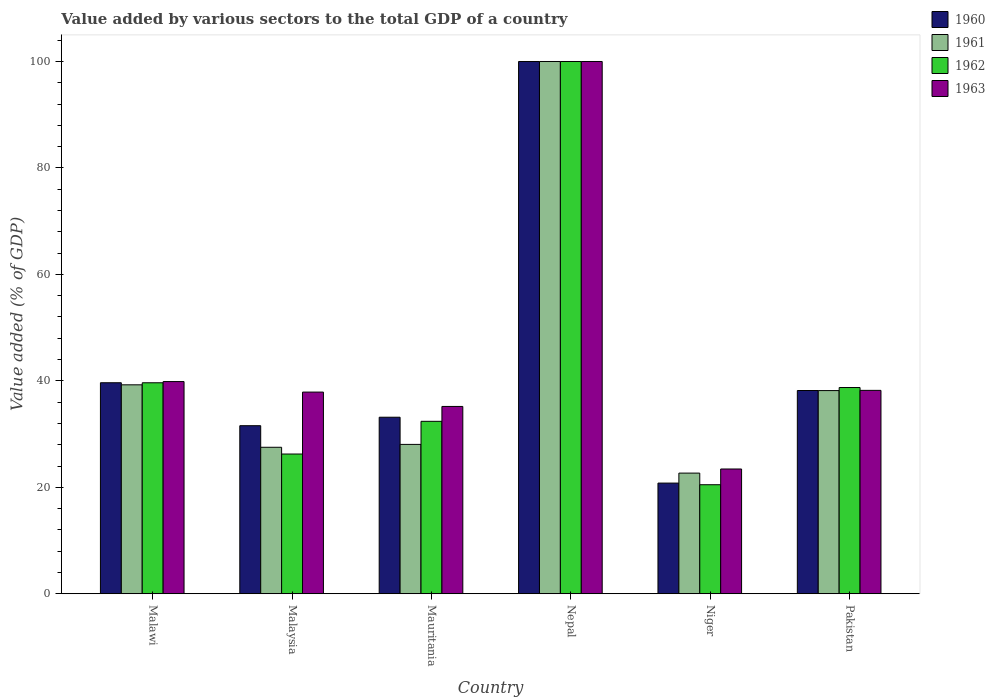How many groups of bars are there?
Keep it short and to the point. 6. How many bars are there on the 5th tick from the left?
Offer a terse response. 4. What is the label of the 2nd group of bars from the left?
Provide a short and direct response. Malaysia. What is the value added by various sectors to the total GDP in 1960 in Pakistan?
Provide a succinct answer. 38.18. Across all countries, what is the minimum value added by various sectors to the total GDP in 1962?
Your answer should be compact. 20.48. In which country was the value added by various sectors to the total GDP in 1962 maximum?
Offer a very short reply. Nepal. In which country was the value added by various sectors to the total GDP in 1963 minimum?
Give a very brief answer. Niger. What is the total value added by various sectors to the total GDP in 1963 in the graph?
Your response must be concise. 274.59. What is the difference between the value added by various sectors to the total GDP in 1961 in Malawi and that in Malaysia?
Provide a succinct answer. 11.73. What is the difference between the value added by various sectors to the total GDP in 1960 in Malaysia and the value added by various sectors to the total GDP in 1963 in Malawi?
Provide a succinct answer. -8.29. What is the average value added by various sectors to the total GDP in 1963 per country?
Make the answer very short. 45.76. What is the difference between the value added by various sectors to the total GDP of/in 1963 and value added by various sectors to the total GDP of/in 1961 in Malawi?
Offer a very short reply. 0.61. What is the ratio of the value added by various sectors to the total GDP in 1960 in Mauritania to that in Niger?
Offer a terse response. 1.6. Is the difference between the value added by various sectors to the total GDP in 1963 in Nepal and Pakistan greater than the difference between the value added by various sectors to the total GDP in 1961 in Nepal and Pakistan?
Your answer should be very brief. No. What is the difference between the highest and the second highest value added by various sectors to the total GDP in 1963?
Offer a very short reply. 61.79. What is the difference between the highest and the lowest value added by various sectors to the total GDP in 1963?
Your answer should be very brief. 76.56. Is the sum of the value added by various sectors to the total GDP in 1963 in Nepal and Pakistan greater than the maximum value added by various sectors to the total GDP in 1960 across all countries?
Offer a very short reply. Yes. What does the 4th bar from the left in Pakistan represents?
Provide a short and direct response. 1963. What does the 4th bar from the right in Niger represents?
Keep it short and to the point. 1960. How many bars are there?
Give a very brief answer. 24. Are all the bars in the graph horizontal?
Keep it short and to the point. No. Are the values on the major ticks of Y-axis written in scientific E-notation?
Provide a succinct answer. No. Does the graph contain grids?
Offer a terse response. No. How many legend labels are there?
Your answer should be very brief. 4. What is the title of the graph?
Provide a short and direct response. Value added by various sectors to the total GDP of a country. What is the label or title of the X-axis?
Provide a short and direct response. Country. What is the label or title of the Y-axis?
Make the answer very short. Value added (% of GDP). What is the Value added (% of GDP) of 1960 in Malawi?
Keep it short and to the point. 39.64. What is the Value added (% of GDP) in 1961 in Malawi?
Provide a succinct answer. 39.25. What is the Value added (% of GDP) of 1962 in Malawi?
Ensure brevity in your answer.  39.64. What is the Value added (% of GDP) in 1963 in Malawi?
Your response must be concise. 39.86. What is the Value added (% of GDP) of 1960 in Malaysia?
Offer a very short reply. 31.57. What is the Value added (% of GDP) in 1961 in Malaysia?
Offer a terse response. 27.52. What is the Value added (% of GDP) in 1962 in Malaysia?
Your answer should be very brief. 26.25. What is the Value added (% of GDP) in 1963 in Malaysia?
Offer a very short reply. 37.89. What is the Value added (% of GDP) in 1960 in Mauritania?
Offer a very short reply. 33.17. What is the Value added (% of GDP) of 1961 in Mauritania?
Offer a terse response. 28.06. What is the Value added (% of GDP) in 1962 in Mauritania?
Your response must be concise. 32.4. What is the Value added (% of GDP) of 1963 in Mauritania?
Your response must be concise. 35.19. What is the Value added (% of GDP) of 1960 in Niger?
Your response must be concise. 20.79. What is the Value added (% of GDP) of 1961 in Niger?
Offer a terse response. 22.67. What is the Value added (% of GDP) of 1962 in Niger?
Your answer should be very brief. 20.48. What is the Value added (% of GDP) of 1963 in Niger?
Provide a succinct answer. 23.44. What is the Value added (% of GDP) in 1960 in Pakistan?
Your answer should be compact. 38.18. What is the Value added (% of GDP) in 1961 in Pakistan?
Your answer should be very brief. 38.17. What is the Value added (% of GDP) of 1962 in Pakistan?
Your answer should be compact. 38.74. What is the Value added (% of GDP) in 1963 in Pakistan?
Offer a very short reply. 38.21. Across all countries, what is the maximum Value added (% of GDP) in 1963?
Make the answer very short. 100. Across all countries, what is the minimum Value added (% of GDP) of 1960?
Offer a terse response. 20.79. Across all countries, what is the minimum Value added (% of GDP) in 1961?
Your response must be concise. 22.67. Across all countries, what is the minimum Value added (% of GDP) in 1962?
Keep it short and to the point. 20.48. Across all countries, what is the minimum Value added (% of GDP) of 1963?
Offer a terse response. 23.44. What is the total Value added (% of GDP) of 1960 in the graph?
Your answer should be compact. 263.36. What is the total Value added (% of GDP) in 1961 in the graph?
Your answer should be very brief. 255.67. What is the total Value added (% of GDP) of 1962 in the graph?
Offer a very short reply. 257.51. What is the total Value added (% of GDP) of 1963 in the graph?
Provide a succinct answer. 274.59. What is the difference between the Value added (% of GDP) in 1960 in Malawi and that in Malaysia?
Your answer should be compact. 8.07. What is the difference between the Value added (% of GDP) of 1961 in Malawi and that in Malaysia?
Provide a succinct answer. 11.73. What is the difference between the Value added (% of GDP) of 1962 in Malawi and that in Malaysia?
Offer a very short reply. 13.39. What is the difference between the Value added (% of GDP) in 1963 in Malawi and that in Malaysia?
Your answer should be compact. 1.98. What is the difference between the Value added (% of GDP) of 1960 in Malawi and that in Mauritania?
Make the answer very short. 6.48. What is the difference between the Value added (% of GDP) of 1961 in Malawi and that in Mauritania?
Make the answer very short. 11.2. What is the difference between the Value added (% of GDP) in 1962 in Malawi and that in Mauritania?
Offer a very short reply. 7.24. What is the difference between the Value added (% of GDP) in 1963 in Malawi and that in Mauritania?
Keep it short and to the point. 4.67. What is the difference between the Value added (% of GDP) of 1960 in Malawi and that in Nepal?
Your answer should be very brief. -60.36. What is the difference between the Value added (% of GDP) in 1961 in Malawi and that in Nepal?
Your answer should be very brief. -60.75. What is the difference between the Value added (% of GDP) in 1962 in Malawi and that in Nepal?
Offer a very short reply. -60.36. What is the difference between the Value added (% of GDP) in 1963 in Malawi and that in Nepal?
Give a very brief answer. -60.14. What is the difference between the Value added (% of GDP) of 1960 in Malawi and that in Niger?
Give a very brief answer. 18.85. What is the difference between the Value added (% of GDP) of 1961 in Malawi and that in Niger?
Ensure brevity in your answer.  16.59. What is the difference between the Value added (% of GDP) of 1962 in Malawi and that in Niger?
Make the answer very short. 19.15. What is the difference between the Value added (% of GDP) of 1963 in Malawi and that in Niger?
Your response must be concise. 16.42. What is the difference between the Value added (% of GDP) in 1960 in Malawi and that in Pakistan?
Your answer should be compact. 1.46. What is the difference between the Value added (% of GDP) in 1961 in Malawi and that in Pakistan?
Offer a terse response. 1.08. What is the difference between the Value added (% of GDP) in 1962 in Malawi and that in Pakistan?
Provide a succinct answer. 0.89. What is the difference between the Value added (% of GDP) of 1963 in Malawi and that in Pakistan?
Give a very brief answer. 1.65. What is the difference between the Value added (% of GDP) in 1960 in Malaysia and that in Mauritania?
Offer a terse response. -1.59. What is the difference between the Value added (% of GDP) of 1961 in Malaysia and that in Mauritania?
Your response must be concise. -0.54. What is the difference between the Value added (% of GDP) of 1962 in Malaysia and that in Mauritania?
Provide a short and direct response. -6.15. What is the difference between the Value added (% of GDP) in 1963 in Malaysia and that in Mauritania?
Offer a terse response. 2.7. What is the difference between the Value added (% of GDP) of 1960 in Malaysia and that in Nepal?
Your answer should be compact. -68.43. What is the difference between the Value added (% of GDP) of 1961 in Malaysia and that in Nepal?
Your response must be concise. -72.48. What is the difference between the Value added (% of GDP) of 1962 in Malaysia and that in Nepal?
Provide a succinct answer. -73.75. What is the difference between the Value added (% of GDP) in 1963 in Malaysia and that in Nepal?
Your response must be concise. -62.11. What is the difference between the Value added (% of GDP) of 1960 in Malaysia and that in Niger?
Offer a very short reply. 10.78. What is the difference between the Value added (% of GDP) of 1961 in Malaysia and that in Niger?
Give a very brief answer. 4.85. What is the difference between the Value added (% of GDP) of 1962 in Malaysia and that in Niger?
Give a very brief answer. 5.77. What is the difference between the Value added (% of GDP) in 1963 in Malaysia and that in Niger?
Offer a terse response. 14.45. What is the difference between the Value added (% of GDP) in 1960 in Malaysia and that in Pakistan?
Your response must be concise. -6.61. What is the difference between the Value added (% of GDP) in 1961 in Malaysia and that in Pakistan?
Provide a short and direct response. -10.65. What is the difference between the Value added (% of GDP) of 1962 in Malaysia and that in Pakistan?
Give a very brief answer. -12.5. What is the difference between the Value added (% of GDP) in 1963 in Malaysia and that in Pakistan?
Your answer should be very brief. -0.32. What is the difference between the Value added (% of GDP) of 1960 in Mauritania and that in Nepal?
Make the answer very short. -66.83. What is the difference between the Value added (% of GDP) of 1961 in Mauritania and that in Nepal?
Keep it short and to the point. -71.94. What is the difference between the Value added (% of GDP) in 1962 in Mauritania and that in Nepal?
Make the answer very short. -67.6. What is the difference between the Value added (% of GDP) of 1963 in Mauritania and that in Nepal?
Keep it short and to the point. -64.81. What is the difference between the Value added (% of GDP) of 1960 in Mauritania and that in Niger?
Offer a very short reply. 12.38. What is the difference between the Value added (% of GDP) in 1961 in Mauritania and that in Niger?
Keep it short and to the point. 5.39. What is the difference between the Value added (% of GDP) of 1962 in Mauritania and that in Niger?
Provide a short and direct response. 11.91. What is the difference between the Value added (% of GDP) of 1963 in Mauritania and that in Niger?
Keep it short and to the point. 11.75. What is the difference between the Value added (% of GDP) of 1960 in Mauritania and that in Pakistan?
Give a very brief answer. -5.02. What is the difference between the Value added (% of GDP) in 1961 in Mauritania and that in Pakistan?
Your answer should be very brief. -10.11. What is the difference between the Value added (% of GDP) of 1962 in Mauritania and that in Pakistan?
Give a very brief answer. -6.35. What is the difference between the Value added (% of GDP) in 1963 in Mauritania and that in Pakistan?
Ensure brevity in your answer.  -3.02. What is the difference between the Value added (% of GDP) of 1960 in Nepal and that in Niger?
Ensure brevity in your answer.  79.21. What is the difference between the Value added (% of GDP) of 1961 in Nepal and that in Niger?
Provide a short and direct response. 77.33. What is the difference between the Value added (% of GDP) of 1962 in Nepal and that in Niger?
Your answer should be very brief. 79.52. What is the difference between the Value added (% of GDP) in 1963 in Nepal and that in Niger?
Offer a very short reply. 76.56. What is the difference between the Value added (% of GDP) of 1960 in Nepal and that in Pakistan?
Offer a very short reply. 61.82. What is the difference between the Value added (% of GDP) in 1961 in Nepal and that in Pakistan?
Your answer should be compact. 61.83. What is the difference between the Value added (% of GDP) in 1962 in Nepal and that in Pakistan?
Your answer should be compact. 61.26. What is the difference between the Value added (% of GDP) in 1963 in Nepal and that in Pakistan?
Provide a succinct answer. 61.79. What is the difference between the Value added (% of GDP) of 1960 in Niger and that in Pakistan?
Make the answer very short. -17.39. What is the difference between the Value added (% of GDP) in 1961 in Niger and that in Pakistan?
Your answer should be compact. -15.5. What is the difference between the Value added (% of GDP) of 1962 in Niger and that in Pakistan?
Provide a short and direct response. -18.26. What is the difference between the Value added (% of GDP) of 1963 in Niger and that in Pakistan?
Keep it short and to the point. -14.77. What is the difference between the Value added (% of GDP) of 1960 in Malawi and the Value added (% of GDP) of 1961 in Malaysia?
Ensure brevity in your answer.  12.13. What is the difference between the Value added (% of GDP) of 1960 in Malawi and the Value added (% of GDP) of 1962 in Malaysia?
Offer a terse response. 13.39. What is the difference between the Value added (% of GDP) of 1960 in Malawi and the Value added (% of GDP) of 1963 in Malaysia?
Your answer should be compact. 1.76. What is the difference between the Value added (% of GDP) of 1961 in Malawi and the Value added (% of GDP) of 1962 in Malaysia?
Your response must be concise. 13. What is the difference between the Value added (% of GDP) of 1961 in Malawi and the Value added (% of GDP) of 1963 in Malaysia?
Ensure brevity in your answer.  1.37. What is the difference between the Value added (% of GDP) of 1962 in Malawi and the Value added (% of GDP) of 1963 in Malaysia?
Offer a terse response. 1.75. What is the difference between the Value added (% of GDP) in 1960 in Malawi and the Value added (% of GDP) in 1961 in Mauritania?
Make the answer very short. 11.59. What is the difference between the Value added (% of GDP) of 1960 in Malawi and the Value added (% of GDP) of 1962 in Mauritania?
Give a very brief answer. 7.25. What is the difference between the Value added (% of GDP) of 1960 in Malawi and the Value added (% of GDP) of 1963 in Mauritania?
Your answer should be very brief. 4.45. What is the difference between the Value added (% of GDP) of 1961 in Malawi and the Value added (% of GDP) of 1962 in Mauritania?
Offer a very short reply. 6.86. What is the difference between the Value added (% of GDP) of 1961 in Malawi and the Value added (% of GDP) of 1963 in Mauritania?
Give a very brief answer. 4.06. What is the difference between the Value added (% of GDP) of 1962 in Malawi and the Value added (% of GDP) of 1963 in Mauritania?
Make the answer very short. 4.45. What is the difference between the Value added (% of GDP) of 1960 in Malawi and the Value added (% of GDP) of 1961 in Nepal?
Give a very brief answer. -60.36. What is the difference between the Value added (% of GDP) of 1960 in Malawi and the Value added (% of GDP) of 1962 in Nepal?
Your answer should be compact. -60.36. What is the difference between the Value added (% of GDP) of 1960 in Malawi and the Value added (% of GDP) of 1963 in Nepal?
Offer a terse response. -60.36. What is the difference between the Value added (% of GDP) in 1961 in Malawi and the Value added (% of GDP) in 1962 in Nepal?
Ensure brevity in your answer.  -60.75. What is the difference between the Value added (% of GDP) in 1961 in Malawi and the Value added (% of GDP) in 1963 in Nepal?
Make the answer very short. -60.75. What is the difference between the Value added (% of GDP) of 1962 in Malawi and the Value added (% of GDP) of 1963 in Nepal?
Provide a short and direct response. -60.36. What is the difference between the Value added (% of GDP) of 1960 in Malawi and the Value added (% of GDP) of 1961 in Niger?
Provide a short and direct response. 16.98. What is the difference between the Value added (% of GDP) in 1960 in Malawi and the Value added (% of GDP) in 1962 in Niger?
Give a very brief answer. 19.16. What is the difference between the Value added (% of GDP) of 1960 in Malawi and the Value added (% of GDP) of 1963 in Niger?
Ensure brevity in your answer.  16.21. What is the difference between the Value added (% of GDP) of 1961 in Malawi and the Value added (% of GDP) of 1962 in Niger?
Offer a very short reply. 18.77. What is the difference between the Value added (% of GDP) in 1961 in Malawi and the Value added (% of GDP) in 1963 in Niger?
Give a very brief answer. 15.81. What is the difference between the Value added (% of GDP) in 1962 in Malawi and the Value added (% of GDP) in 1963 in Niger?
Give a very brief answer. 16.2. What is the difference between the Value added (% of GDP) of 1960 in Malawi and the Value added (% of GDP) of 1961 in Pakistan?
Offer a very short reply. 1.48. What is the difference between the Value added (% of GDP) of 1960 in Malawi and the Value added (% of GDP) of 1962 in Pakistan?
Offer a very short reply. 0.9. What is the difference between the Value added (% of GDP) of 1960 in Malawi and the Value added (% of GDP) of 1963 in Pakistan?
Your answer should be very brief. 1.43. What is the difference between the Value added (% of GDP) in 1961 in Malawi and the Value added (% of GDP) in 1962 in Pakistan?
Keep it short and to the point. 0.51. What is the difference between the Value added (% of GDP) in 1961 in Malawi and the Value added (% of GDP) in 1963 in Pakistan?
Offer a terse response. 1.04. What is the difference between the Value added (% of GDP) in 1962 in Malawi and the Value added (% of GDP) in 1963 in Pakistan?
Give a very brief answer. 1.43. What is the difference between the Value added (% of GDP) of 1960 in Malaysia and the Value added (% of GDP) of 1961 in Mauritania?
Give a very brief answer. 3.51. What is the difference between the Value added (% of GDP) of 1960 in Malaysia and the Value added (% of GDP) of 1962 in Mauritania?
Make the answer very short. -0.82. What is the difference between the Value added (% of GDP) in 1960 in Malaysia and the Value added (% of GDP) in 1963 in Mauritania?
Keep it short and to the point. -3.62. What is the difference between the Value added (% of GDP) in 1961 in Malaysia and the Value added (% of GDP) in 1962 in Mauritania?
Make the answer very short. -4.88. What is the difference between the Value added (% of GDP) of 1961 in Malaysia and the Value added (% of GDP) of 1963 in Mauritania?
Offer a terse response. -7.67. What is the difference between the Value added (% of GDP) of 1962 in Malaysia and the Value added (% of GDP) of 1963 in Mauritania?
Make the answer very short. -8.94. What is the difference between the Value added (% of GDP) of 1960 in Malaysia and the Value added (% of GDP) of 1961 in Nepal?
Give a very brief answer. -68.43. What is the difference between the Value added (% of GDP) in 1960 in Malaysia and the Value added (% of GDP) in 1962 in Nepal?
Your response must be concise. -68.43. What is the difference between the Value added (% of GDP) of 1960 in Malaysia and the Value added (% of GDP) of 1963 in Nepal?
Keep it short and to the point. -68.43. What is the difference between the Value added (% of GDP) of 1961 in Malaysia and the Value added (% of GDP) of 1962 in Nepal?
Your answer should be compact. -72.48. What is the difference between the Value added (% of GDP) of 1961 in Malaysia and the Value added (% of GDP) of 1963 in Nepal?
Your response must be concise. -72.48. What is the difference between the Value added (% of GDP) of 1962 in Malaysia and the Value added (% of GDP) of 1963 in Nepal?
Your answer should be very brief. -73.75. What is the difference between the Value added (% of GDP) of 1960 in Malaysia and the Value added (% of GDP) of 1961 in Niger?
Your response must be concise. 8.91. What is the difference between the Value added (% of GDP) of 1960 in Malaysia and the Value added (% of GDP) of 1962 in Niger?
Your answer should be compact. 11.09. What is the difference between the Value added (% of GDP) in 1960 in Malaysia and the Value added (% of GDP) in 1963 in Niger?
Provide a succinct answer. 8.13. What is the difference between the Value added (% of GDP) of 1961 in Malaysia and the Value added (% of GDP) of 1962 in Niger?
Provide a short and direct response. 7.04. What is the difference between the Value added (% of GDP) in 1961 in Malaysia and the Value added (% of GDP) in 1963 in Niger?
Provide a succinct answer. 4.08. What is the difference between the Value added (% of GDP) in 1962 in Malaysia and the Value added (% of GDP) in 1963 in Niger?
Make the answer very short. 2.81. What is the difference between the Value added (% of GDP) in 1960 in Malaysia and the Value added (% of GDP) in 1961 in Pakistan?
Keep it short and to the point. -6.6. What is the difference between the Value added (% of GDP) in 1960 in Malaysia and the Value added (% of GDP) in 1962 in Pakistan?
Your response must be concise. -7.17. What is the difference between the Value added (% of GDP) of 1960 in Malaysia and the Value added (% of GDP) of 1963 in Pakistan?
Provide a short and direct response. -6.64. What is the difference between the Value added (% of GDP) of 1961 in Malaysia and the Value added (% of GDP) of 1962 in Pakistan?
Your answer should be very brief. -11.23. What is the difference between the Value added (% of GDP) of 1961 in Malaysia and the Value added (% of GDP) of 1963 in Pakistan?
Your response must be concise. -10.69. What is the difference between the Value added (% of GDP) in 1962 in Malaysia and the Value added (% of GDP) in 1963 in Pakistan?
Give a very brief answer. -11.96. What is the difference between the Value added (% of GDP) in 1960 in Mauritania and the Value added (% of GDP) in 1961 in Nepal?
Your answer should be very brief. -66.83. What is the difference between the Value added (% of GDP) of 1960 in Mauritania and the Value added (% of GDP) of 1962 in Nepal?
Ensure brevity in your answer.  -66.83. What is the difference between the Value added (% of GDP) in 1960 in Mauritania and the Value added (% of GDP) in 1963 in Nepal?
Offer a very short reply. -66.83. What is the difference between the Value added (% of GDP) in 1961 in Mauritania and the Value added (% of GDP) in 1962 in Nepal?
Your answer should be compact. -71.94. What is the difference between the Value added (% of GDP) of 1961 in Mauritania and the Value added (% of GDP) of 1963 in Nepal?
Offer a terse response. -71.94. What is the difference between the Value added (% of GDP) in 1962 in Mauritania and the Value added (% of GDP) in 1963 in Nepal?
Ensure brevity in your answer.  -67.6. What is the difference between the Value added (% of GDP) of 1960 in Mauritania and the Value added (% of GDP) of 1961 in Niger?
Offer a very short reply. 10.5. What is the difference between the Value added (% of GDP) in 1960 in Mauritania and the Value added (% of GDP) in 1962 in Niger?
Your answer should be very brief. 12.68. What is the difference between the Value added (% of GDP) in 1960 in Mauritania and the Value added (% of GDP) in 1963 in Niger?
Give a very brief answer. 9.73. What is the difference between the Value added (% of GDP) of 1961 in Mauritania and the Value added (% of GDP) of 1962 in Niger?
Keep it short and to the point. 7.58. What is the difference between the Value added (% of GDP) in 1961 in Mauritania and the Value added (% of GDP) in 1963 in Niger?
Your answer should be very brief. 4.62. What is the difference between the Value added (% of GDP) in 1962 in Mauritania and the Value added (% of GDP) in 1963 in Niger?
Provide a succinct answer. 8.96. What is the difference between the Value added (% of GDP) in 1960 in Mauritania and the Value added (% of GDP) in 1961 in Pakistan?
Offer a terse response. -5. What is the difference between the Value added (% of GDP) in 1960 in Mauritania and the Value added (% of GDP) in 1962 in Pakistan?
Provide a short and direct response. -5.58. What is the difference between the Value added (% of GDP) in 1960 in Mauritania and the Value added (% of GDP) in 1963 in Pakistan?
Make the answer very short. -5.04. What is the difference between the Value added (% of GDP) in 1961 in Mauritania and the Value added (% of GDP) in 1962 in Pakistan?
Provide a succinct answer. -10.69. What is the difference between the Value added (% of GDP) of 1961 in Mauritania and the Value added (% of GDP) of 1963 in Pakistan?
Provide a short and direct response. -10.15. What is the difference between the Value added (% of GDP) of 1962 in Mauritania and the Value added (% of GDP) of 1963 in Pakistan?
Your answer should be very brief. -5.81. What is the difference between the Value added (% of GDP) in 1960 in Nepal and the Value added (% of GDP) in 1961 in Niger?
Make the answer very short. 77.33. What is the difference between the Value added (% of GDP) in 1960 in Nepal and the Value added (% of GDP) in 1962 in Niger?
Your answer should be very brief. 79.52. What is the difference between the Value added (% of GDP) of 1960 in Nepal and the Value added (% of GDP) of 1963 in Niger?
Offer a terse response. 76.56. What is the difference between the Value added (% of GDP) in 1961 in Nepal and the Value added (% of GDP) in 1962 in Niger?
Ensure brevity in your answer.  79.52. What is the difference between the Value added (% of GDP) of 1961 in Nepal and the Value added (% of GDP) of 1963 in Niger?
Your response must be concise. 76.56. What is the difference between the Value added (% of GDP) in 1962 in Nepal and the Value added (% of GDP) in 1963 in Niger?
Provide a short and direct response. 76.56. What is the difference between the Value added (% of GDP) of 1960 in Nepal and the Value added (% of GDP) of 1961 in Pakistan?
Offer a terse response. 61.83. What is the difference between the Value added (% of GDP) in 1960 in Nepal and the Value added (% of GDP) in 1962 in Pakistan?
Your response must be concise. 61.26. What is the difference between the Value added (% of GDP) in 1960 in Nepal and the Value added (% of GDP) in 1963 in Pakistan?
Offer a terse response. 61.79. What is the difference between the Value added (% of GDP) in 1961 in Nepal and the Value added (% of GDP) in 1962 in Pakistan?
Offer a terse response. 61.26. What is the difference between the Value added (% of GDP) in 1961 in Nepal and the Value added (% of GDP) in 1963 in Pakistan?
Provide a short and direct response. 61.79. What is the difference between the Value added (% of GDP) of 1962 in Nepal and the Value added (% of GDP) of 1963 in Pakistan?
Your answer should be very brief. 61.79. What is the difference between the Value added (% of GDP) of 1960 in Niger and the Value added (% of GDP) of 1961 in Pakistan?
Offer a very short reply. -17.38. What is the difference between the Value added (% of GDP) in 1960 in Niger and the Value added (% of GDP) in 1962 in Pakistan?
Provide a succinct answer. -17.95. What is the difference between the Value added (% of GDP) in 1960 in Niger and the Value added (% of GDP) in 1963 in Pakistan?
Provide a succinct answer. -17.42. What is the difference between the Value added (% of GDP) in 1961 in Niger and the Value added (% of GDP) in 1962 in Pakistan?
Make the answer very short. -16.08. What is the difference between the Value added (% of GDP) of 1961 in Niger and the Value added (% of GDP) of 1963 in Pakistan?
Ensure brevity in your answer.  -15.54. What is the difference between the Value added (% of GDP) in 1962 in Niger and the Value added (% of GDP) in 1963 in Pakistan?
Provide a short and direct response. -17.73. What is the average Value added (% of GDP) of 1960 per country?
Offer a very short reply. 43.89. What is the average Value added (% of GDP) of 1961 per country?
Offer a very short reply. 42.61. What is the average Value added (% of GDP) of 1962 per country?
Your answer should be very brief. 42.92. What is the average Value added (% of GDP) in 1963 per country?
Your answer should be very brief. 45.76. What is the difference between the Value added (% of GDP) of 1960 and Value added (% of GDP) of 1961 in Malawi?
Offer a terse response. 0.39. What is the difference between the Value added (% of GDP) of 1960 and Value added (% of GDP) of 1962 in Malawi?
Keep it short and to the point. 0.01. What is the difference between the Value added (% of GDP) in 1960 and Value added (% of GDP) in 1963 in Malawi?
Offer a very short reply. -0.22. What is the difference between the Value added (% of GDP) in 1961 and Value added (% of GDP) in 1962 in Malawi?
Ensure brevity in your answer.  -0.38. What is the difference between the Value added (% of GDP) of 1961 and Value added (% of GDP) of 1963 in Malawi?
Offer a very short reply. -0.61. What is the difference between the Value added (% of GDP) of 1962 and Value added (% of GDP) of 1963 in Malawi?
Offer a terse response. -0.23. What is the difference between the Value added (% of GDP) in 1960 and Value added (% of GDP) in 1961 in Malaysia?
Give a very brief answer. 4.05. What is the difference between the Value added (% of GDP) of 1960 and Value added (% of GDP) of 1962 in Malaysia?
Make the answer very short. 5.32. What is the difference between the Value added (% of GDP) of 1960 and Value added (% of GDP) of 1963 in Malaysia?
Provide a succinct answer. -6.31. What is the difference between the Value added (% of GDP) in 1961 and Value added (% of GDP) in 1962 in Malaysia?
Provide a succinct answer. 1.27. What is the difference between the Value added (% of GDP) of 1961 and Value added (% of GDP) of 1963 in Malaysia?
Offer a very short reply. -10.37. What is the difference between the Value added (% of GDP) in 1962 and Value added (% of GDP) in 1963 in Malaysia?
Make the answer very short. -11.64. What is the difference between the Value added (% of GDP) in 1960 and Value added (% of GDP) in 1961 in Mauritania?
Ensure brevity in your answer.  5.11. What is the difference between the Value added (% of GDP) of 1960 and Value added (% of GDP) of 1962 in Mauritania?
Provide a succinct answer. 0.77. What is the difference between the Value added (% of GDP) in 1960 and Value added (% of GDP) in 1963 in Mauritania?
Keep it short and to the point. -2.02. What is the difference between the Value added (% of GDP) of 1961 and Value added (% of GDP) of 1962 in Mauritania?
Give a very brief answer. -4.34. What is the difference between the Value added (% of GDP) of 1961 and Value added (% of GDP) of 1963 in Mauritania?
Give a very brief answer. -7.13. What is the difference between the Value added (% of GDP) in 1962 and Value added (% of GDP) in 1963 in Mauritania?
Make the answer very short. -2.79. What is the difference between the Value added (% of GDP) of 1960 and Value added (% of GDP) of 1962 in Nepal?
Offer a very short reply. 0. What is the difference between the Value added (% of GDP) in 1960 and Value added (% of GDP) in 1961 in Niger?
Provide a succinct answer. -1.88. What is the difference between the Value added (% of GDP) of 1960 and Value added (% of GDP) of 1962 in Niger?
Make the answer very short. 0.31. What is the difference between the Value added (% of GDP) of 1960 and Value added (% of GDP) of 1963 in Niger?
Your answer should be very brief. -2.65. What is the difference between the Value added (% of GDP) in 1961 and Value added (% of GDP) in 1962 in Niger?
Ensure brevity in your answer.  2.18. What is the difference between the Value added (% of GDP) of 1961 and Value added (% of GDP) of 1963 in Niger?
Ensure brevity in your answer.  -0.77. What is the difference between the Value added (% of GDP) in 1962 and Value added (% of GDP) in 1963 in Niger?
Ensure brevity in your answer.  -2.96. What is the difference between the Value added (% of GDP) in 1960 and Value added (% of GDP) in 1961 in Pakistan?
Offer a very short reply. 0.01. What is the difference between the Value added (% of GDP) of 1960 and Value added (% of GDP) of 1962 in Pakistan?
Offer a terse response. -0.56. What is the difference between the Value added (% of GDP) of 1960 and Value added (% of GDP) of 1963 in Pakistan?
Offer a terse response. -0.03. What is the difference between the Value added (% of GDP) of 1961 and Value added (% of GDP) of 1962 in Pakistan?
Make the answer very short. -0.58. What is the difference between the Value added (% of GDP) in 1961 and Value added (% of GDP) in 1963 in Pakistan?
Keep it short and to the point. -0.04. What is the difference between the Value added (% of GDP) in 1962 and Value added (% of GDP) in 1963 in Pakistan?
Ensure brevity in your answer.  0.53. What is the ratio of the Value added (% of GDP) of 1960 in Malawi to that in Malaysia?
Offer a terse response. 1.26. What is the ratio of the Value added (% of GDP) of 1961 in Malawi to that in Malaysia?
Provide a short and direct response. 1.43. What is the ratio of the Value added (% of GDP) in 1962 in Malawi to that in Malaysia?
Provide a short and direct response. 1.51. What is the ratio of the Value added (% of GDP) in 1963 in Malawi to that in Malaysia?
Your response must be concise. 1.05. What is the ratio of the Value added (% of GDP) in 1960 in Malawi to that in Mauritania?
Provide a succinct answer. 1.2. What is the ratio of the Value added (% of GDP) of 1961 in Malawi to that in Mauritania?
Ensure brevity in your answer.  1.4. What is the ratio of the Value added (% of GDP) in 1962 in Malawi to that in Mauritania?
Provide a short and direct response. 1.22. What is the ratio of the Value added (% of GDP) in 1963 in Malawi to that in Mauritania?
Your answer should be very brief. 1.13. What is the ratio of the Value added (% of GDP) of 1960 in Malawi to that in Nepal?
Offer a very short reply. 0.4. What is the ratio of the Value added (% of GDP) of 1961 in Malawi to that in Nepal?
Make the answer very short. 0.39. What is the ratio of the Value added (% of GDP) of 1962 in Malawi to that in Nepal?
Your answer should be compact. 0.4. What is the ratio of the Value added (% of GDP) in 1963 in Malawi to that in Nepal?
Your answer should be very brief. 0.4. What is the ratio of the Value added (% of GDP) of 1960 in Malawi to that in Niger?
Your answer should be compact. 1.91. What is the ratio of the Value added (% of GDP) in 1961 in Malawi to that in Niger?
Your response must be concise. 1.73. What is the ratio of the Value added (% of GDP) of 1962 in Malawi to that in Niger?
Your response must be concise. 1.94. What is the ratio of the Value added (% of GDP) in 1963 in Malawi to that in Niger?
Make the answer very short. 1.7. What is the ratio of the Value added (% of GDP) in 1960 in Malawi to that in Pakistan?
Make the answer very short. 1.04. What is the ratio of the Value added (% of GDP) of 1961 in Malawi to that in Pakistan?
Keep it short and to the point. 1.03. What is the ratio of the Value added (% of GDP) of 1963 in Malawi to that in Pakistan?
Make the answer very short. 1.04. What is the ratio of the Value added (% of GDP) of 1961 in Malaysia to that in Mauritania?
Give a very brief answer. 0.98. What is the ratio of the Value added (% of GDP) in 1962 in Malaysia to that in Mauritania?
Your answer should be very brief. 0.81. What is the ratio of the Value added (% of GDP) of 1963 in Malaysia to that in Mauritania?
Your response must be concise. 1.08. What is the ratio of the Value added (% of GDP) of 1960 in Malaysia to that in Nepal?
Your answer should be compact. 0.32. What is the ratio of the Value added (% of GDP) in 1961 in Malaysia to that in Nepal?
Keep it short and to the point. 0.28. What is the ratio of the Value added (% of GDP) of 1962 in Malaysia to that in Nepal?
Ensure brevity in your answer.  0.26. What is the ratio of the Value added (% of GDP) in 1963 in Malaysia to that in Nepal?
Make the answer very short. 0.38. What is the ratio of the Value added (% of GDP) in 1960 in Malaysia to that in Niger?
Provide a short and direct response. 1.52. What is the ratio of the Value added (% of GDP) in 1961 in Malaysia to that in Niger?
Give a very brief answer. 1.21. What is the ratio of the Value added (% of GDP) in 1962 in Malaysia to that in Niger?
Your answer should be very brief. 1.28. What is the ratio of the Value added (% of GDP) of 1963 in Malaysia to that in Niger?
Keep it short and to the point. 1.62. What is the ratio of the Value added (% of GDP) of 1960 in Malaysia to that in Pakistan?
Ensure brevity in your answer.  0.83. What is the ratio of the Value added (% of GDP) in 1961 in Malaysia to that in Pakistan?
Make the answer very short. 0.72. What is the ratio of the Value added (% of GDP) in 1962 in Malaysia to that in Pakistan?
Provide a succinct answer. 0.68. What is the ratio of the Value added (% of GDP) of 1963 in Malaysia to that in Pakistan?
Offer a terse response. 0.99. What is the ratio of the Value added (% of GDP) of 1960 in Mauritania to that in Nepal?
Provide a short and direct response. 0.33. What is the ratio of the Value added (% of GDP) in 1961 in Mauritania to that in Nepal?
Provide a short and direct response. 0.28. What is the ratio of the Value added (% of GDP) of 1962 in Mauritania to that in Nepal?
Provide a succinct answer. 0.32. What is the ratio of the Value added (% of GDP) of 1963 in Mauritania to that in Nepal?
Your response must be concise. 0.35. What is the ratio of the Value added (% of GDP) of 1960 in Mauritania to that in Niger?
Provide a succinct answer. 1.6. What is the ratio of the Value added (% of GDP) of 1961 in Mauritania to that in Niger?
Your answer should be compact. 1.24. What is the ratio of the Value added (% of GDP) of 1962 in Mauritania to that in Niger?
Provide a succinct answer. 1.58. What is the ratio of the Value added (% of GDP) of 1963 in Mauritania to that in Niger?
Give a very brief answer. 1.5. What is the ratio of the Value added (% of GDP) in 1960 in Mauritania to that in Pakistan?
Give a very brief answer. 0.87. What is the ratio of the Value added (% of GDP) of 1961 in Mauritania to that in Pakistan?
Keep it short and to the point. 0.74. What is the ratio of the Value added (% of GDP) of 1962 in Mauritania to that in Pakistan?
Keep it short and to the point. 0.84. What is the ratio of the Value added (% of GDP) in 1963 in Mauritania to that in Pakistan?
Make the answer very short. 0.92. What is the ratio of the Value added (% of GDP) of 1960 in Nepal to that in Niger?
Your answer should be very brief. 4.81. What is the ratio of the Value added (% of GDP) in 1961 in Nepal to that in Niger?
Ensure brevity in your answer.  4.41. What is the ratio of the Value added (% of GDP) of 1962 in Nepal to that in Niger?
Offer a very short reply. 4.88. What is the ratio of the Value added (% of GDP) in 1963 in Nepal to that in Niger?
Offer a terse response. 4.27. What is the ratio of the Value added (% of GDP) of 1960 in Nepal to that in Pakistan?
Offer a terse response. 2.62. What is the ratio of the Value added (% of GDP) in 1961 in Nepal to that in Pakistan?
Your response must be concise. 2.62. What is the ratio of the Value added (% of GDP) of 1962 in Nepal to that in Pakistan?
Your answer should be very brief. 2.58. What is the ratio of the Value added (% of GDP) in 1963 in Nepal to that in Pakistan?
Your response must be concise. 2.62. What is the ratio of the Value added (% of GDP) in 1960 in Niger to that in Pakistan?
Keep it short and to the point. 0.54. What is the ratio of the Value added (% of GDP) in 1961 in Niger to that in Pakistan?
Your response must be concise. 0.59. What is the ratio of the Value added (% of GDP) of 1962 in Niger to that in Pakistan?
Offer a terse response. 0.53. What is the ratio of the Value added (% of GDP) in 1963 in Niger to that in Pakistan?
Offer a very short reply. 0.61. What is the difference between the highest and the second highest Value added (% of GDP) of 1960?
Provide a succinct answer. 60.36. What is the difference between the highest and the second highest Value added (% of GDP) in 1961?
Your answer should be compact. 60.75. What is the difference between the highest and the second highest Value added (% of GDP) of 1962?
Make the answer very short. 60.36. What is the difference between the highest and the second highest Value added (% of GDP) of 1963?
Your response must be concise. 60.14. What is the difference between the highest and the lowest Value added (% of GDP) in 1960?
Offer a very short reply. 79.21. What is the difference between the highest and the lowest Value added (% of GDP) in 1961?
Offer a very short reply. 77.33. What is the difference between the highest and the lowest Value added (% of GDP) of 1962?
Make the answer very short. 79.52. What is the difference between the highest and the lowest Value added (% of GDP) of 1963?
Ensure brevity in your answer.  76.56. 